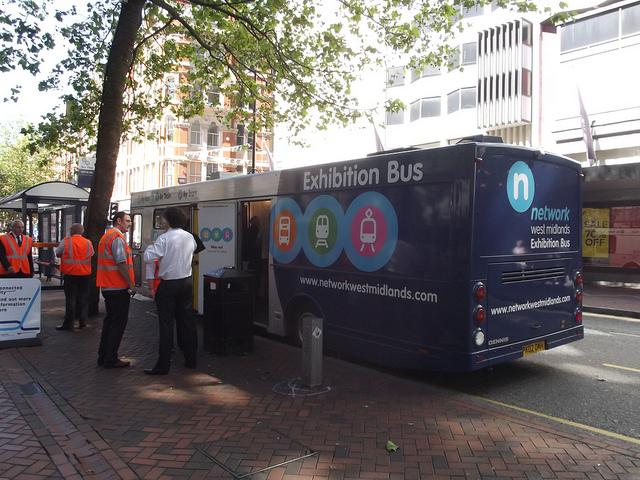What kind of bus is parked in front of the men? exhibition bus 